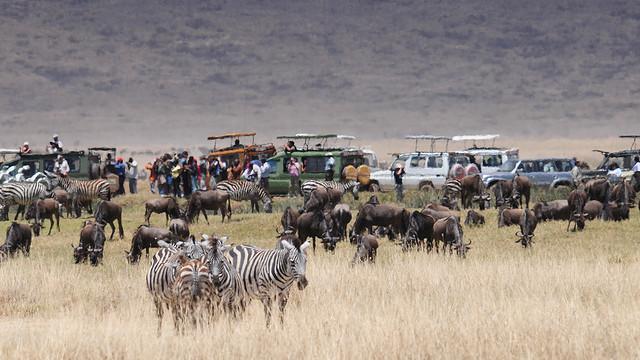What kind of animals are these in relation to their diets?
Select the accurate answer and provide justification: `Answer: choice
Rationale: srationale.`
Options: Nonmajors, omnivores, carnivores, herbivores. Answer: herbivores.
Rationale: These animals are zebras and wildebeests. they have plant-based diets. 